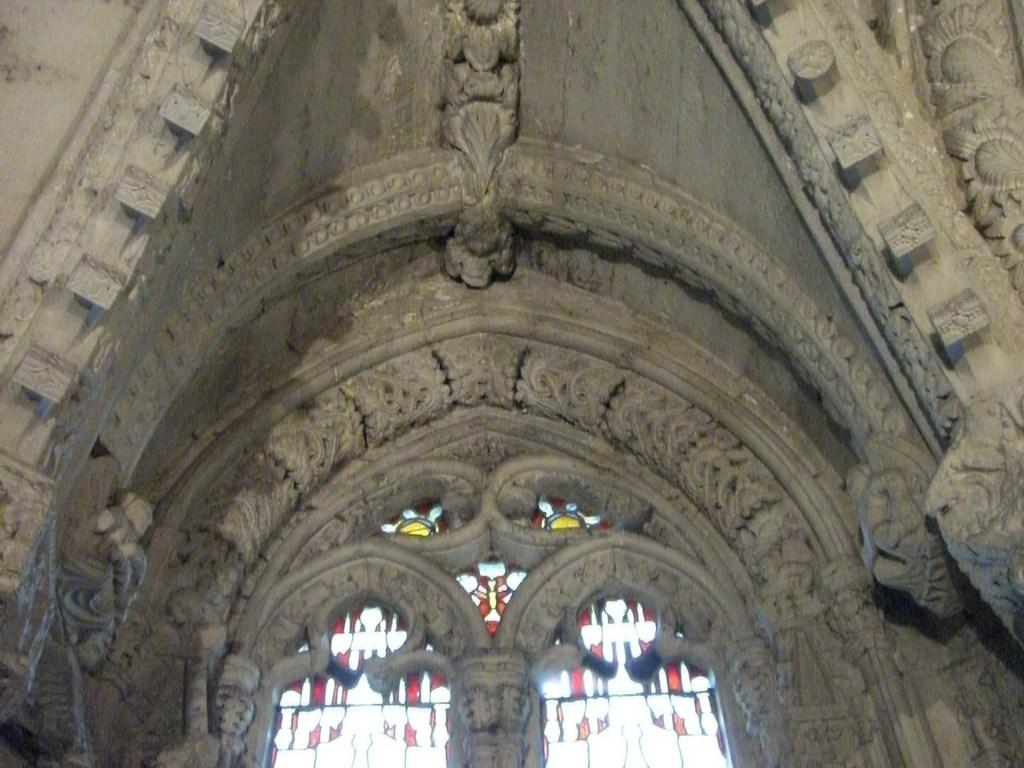What is the main feature of the image? There is a wall in the image. What color is the wall? The wall is brown in color. Are there any patterns or designs on the wall? Yes, there are designs on the wall. What else can be seen in the image besides the wall? There are windows in the image. Can you see any signs of regret on the wall in the image? There is no indication of regret in the image, as it only features a brown wall with designs and windows. 